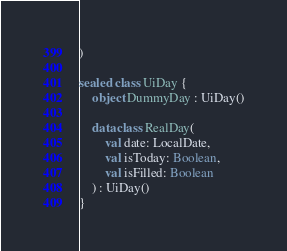<code> <loc_0><loc_0><loc_500><loc_500><_Kotlin_>)

sealed class UiDay {
    object DummyDay : UiDay()

    data class RealDay(
        val date: LocalDate,
        val isToday: Boolean,
        val isFilled: Boolean
    ) : UiDay()
}

</code> 